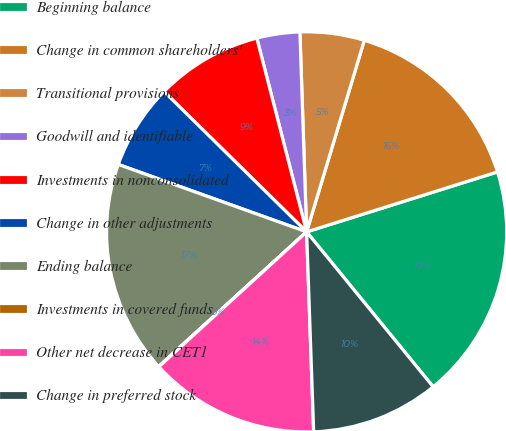<chart> <loc_0><loc_0><loc_500><loc_500><pie_chart><fcel>Beginning balance<fcel>Change in common shareholders'<fcel>Transitional provisions<fcel>Goodwill and identifiable<fcel>Investments in nonconsolidated<fcel>Change in other adjustments<fcel>Ending balance<fcel>Investments in covered funds<fcel>Other net decrease in CET1<fcel>Change in preferred stock<nl><fcel>18.94%<fcel>15.5%<fcel>5.19%<fcel>3.47%<fcel>8.62%<fcel>6.9%<fcel>17.22%<fcel>0.03%<fcel>13.78%<fcel>10.34%<nl></chart> 